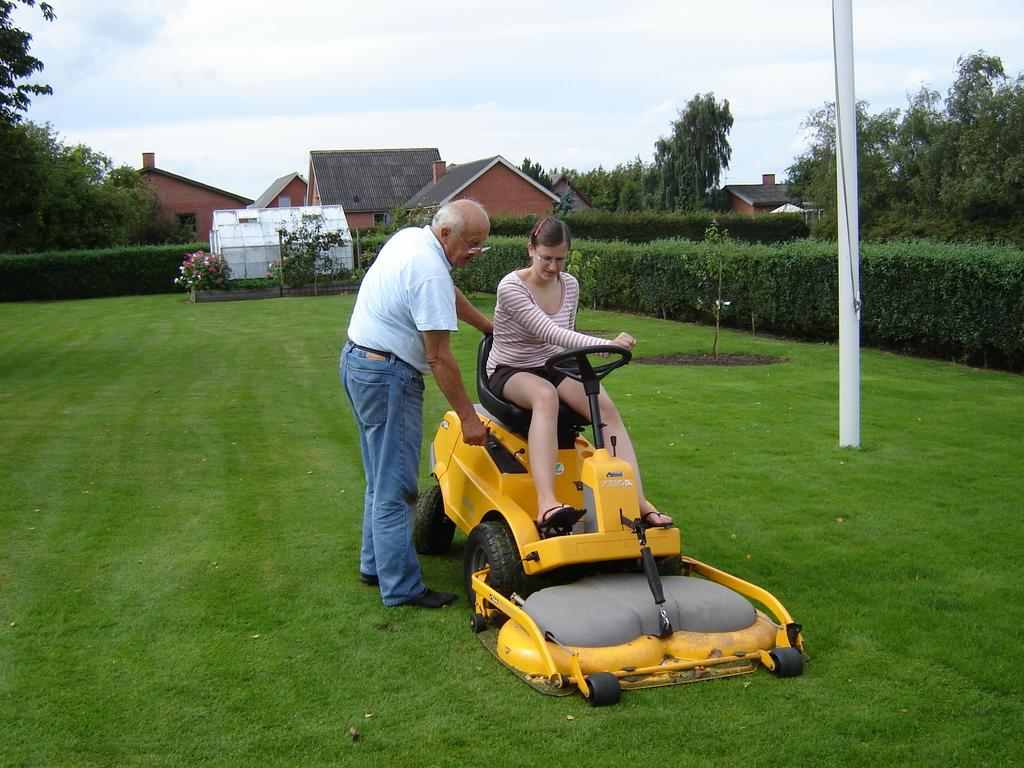What is the main subject of the image? There is a person sitting on a lawn tractor in the image. Can you describe the other person in the image? There is another person standing in the image. What can be seen in the background of the image? There are plants, houses, trees, and the sky visible in the background of the image. What type of stove can be seen in the image? There is no stove present in the image. How does the match interact with the person sitting on the lawn tractor? There is no match present in the image, so it cannot interact with the person sitting on the lawn tractor. 